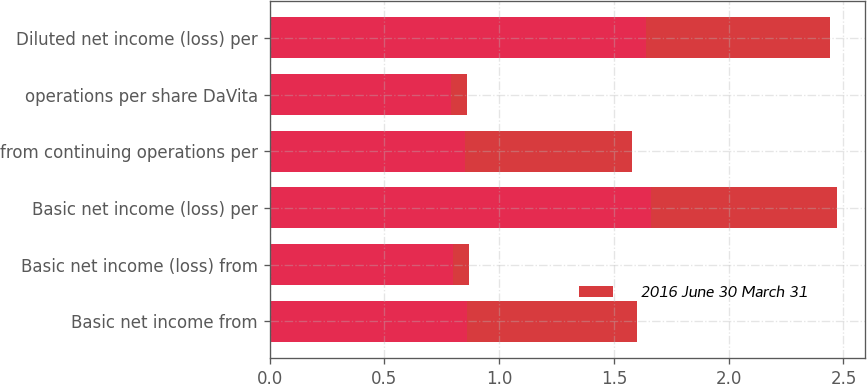Convert chart to OTSL. <chart><loc_0><loc_0><loc_500><loc_500><stacked_bar_chart><ecel><fcel>Basic net income from<fcel>Basic net income (loss) from<fcel>Basic net income (loss) per<fcel>from continuing operations per<fcel>operations per share DaVita<fcel>Diluted net income (loss) per<nl><fcel>nan<fcel>0.86<fcel>0.8<fcel>1.66<fcel>0.85<fcel>0.79<fcel>1.64<nl><fcel>2016 June 30 March 31<fcel>0.74<fcel>0.07<fcel>0.81<fcel>0.73<fcel>0.07<fcel>0.8<nl></chart> 